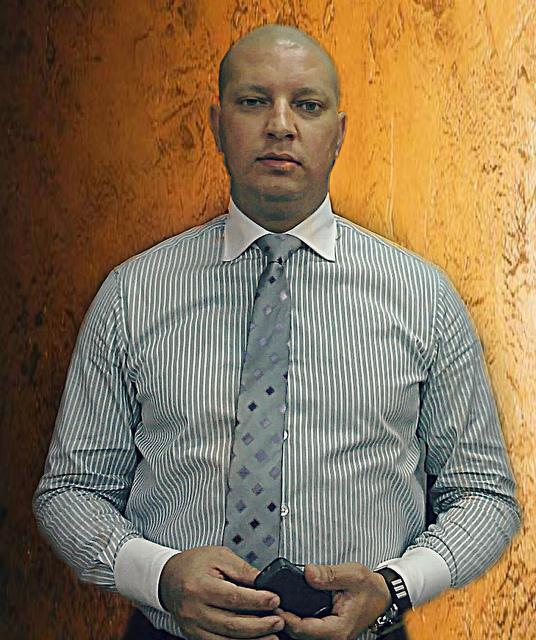How many diamond shapes is on the guy's tie?
Keep it brief. 35. What shape is on his neckwear?
Give a very brief answer. Diamond. What is the man holding?
Write a very short answer. Phone. What is the man's hairstyle?
Short answer required. Bald. Is the man wearing a bow tie?
Answer briefly. No. 